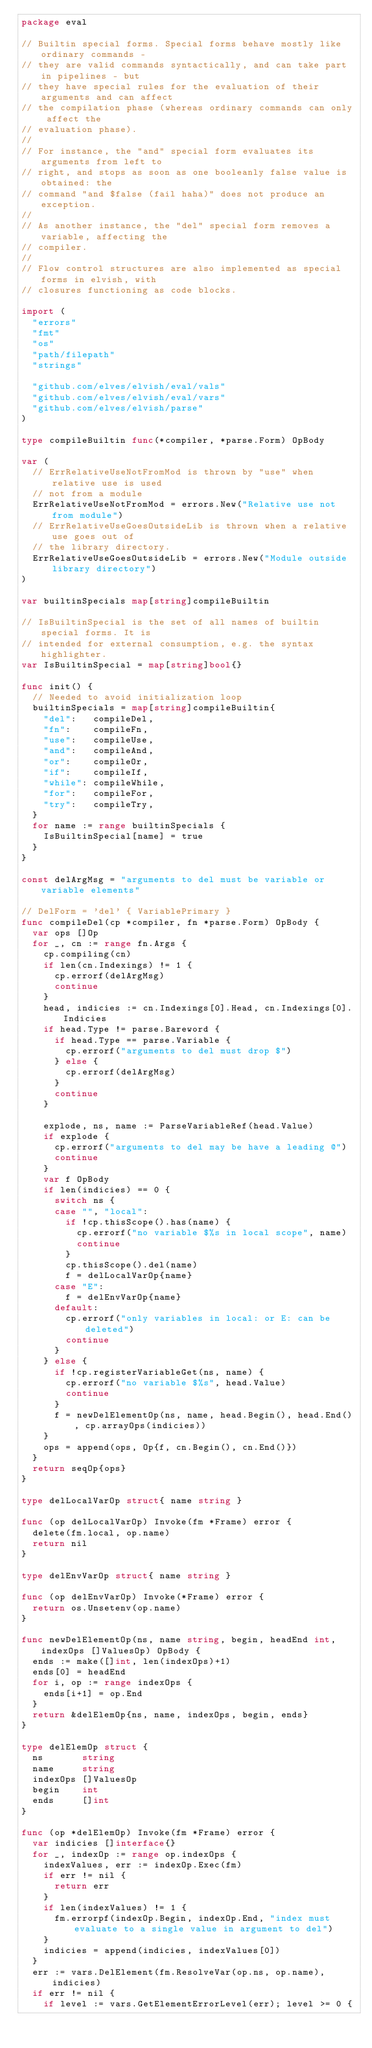Convert code to text. <code><loc_0><loc_0><loc_500><loc_500><_Go_>package eval

// Builtin special forms. Special forms behave mostly like ordinary commands -
// they are valid commands syntactically, and can take part in pipelines - but
// they have special rules for the evaluation of their arguments and can affect
// the compilation phase (whereas ordinary commands can only affect the
// evaluation phase).
//
// For instance, the "and" special form evaluates its arguments from left to
// right, and stops as soon as one booleanly false value is obtained: the
// command "and $false (fail haha)" does not produce an exception.
//
// As another instance, the "del" special form removes a variable, affecting the
// compiler.
//
// Flow control structures are also implemented as special forms in elvish, with
// closures functioning as code blocks.

import (
	"errors"
	"fmt"
	"os"
	"path/filepath"
	"strings"

	"github.com/elves/elvish/eval/vals"
	"github.com/elves/elvish/eval/vars"
	"github.com/elves/elvish/parse"
)

type compileBuiltin func(*compiler, *parse.Form) OpBody

var (
	// ErrRelativeUseNotFromMod is thrown by "use" when relative use is used
	// not from a module
	ErrRelativeUseNotFromMod = errors.New("Relative use not from module")
	// ErrRelativeUseGoesOutsideLib is thrown when a relative use goes out of
	// the library directory.
	ErrRelativeUseGoesOutsideLib = errors.New("Module outside library directory")
)

var builtinSpecials map[string]compileBuiltin

// IsBuiltinSpecial is the set of all names of builtin special forms. It is
// intended for external consumption, e.g. the syntax highlighter.
var IsBuiltinSpecial = map[string]bool{}

func init() {
	// Needed to avoid initialization loop
	builtinSpecials = map[string]compileBuiltin{
		"del":   compileDel,
		"fn":    compileFn,
		"use":   compileUse,
		"and":   compileAnd,
		"or":    compileOr,
		"if":    compileIf,
		"while": compileWhile,
		"for":   compileFor,
		"try":   compileTry,
	}
	for name := range builtinSpecials {
		IsBuiltinSpecial[name] = true
	}
}

const delArgMsg = "arguments to del must be variable or variable elements"

// DelForm = 'del' { VariablePrimary }
func compileDel(cp *compiler, fn *parse.Form) OpBody {
	var ops []Op
	for _, cn := range fn.Args {
		cp.compiling(cn)
		if len(cn.Indexings) != 1 {
			cp.errorf(delArgMsg)
			continue
		}
		head, indicies := cn.Indexings[0].Head, cn.Indexings[0].Indicies
		if head.Type != parse.Bareword {
			if head.Type == parse.Variable {
				cp.errorf("arguments to del must drop $")
			} else {
				cp.errorf(delArgMsg)
			}
			continue
		}

		explode, ns, name := ParseVariableRef(head.Value)
		if explode {
			cp.errorf("arguments to del may be have a leading @")
			continue
		}
		var f OpBody
		if len(indicies) == 0 {
			switch ns {
			case "", "local":
				if !cp.thisScope().has(name) {
					cp.errorf("no variable $%s in local scope", name)
					continue
				}
				cp.thisScope().del(name)
				f = delLocalVarOp{name}
			case "E":
				f = delEnvVarOp{name}
			default:
				cp.errorf("only variables in local: or E: can be deleted")
				continue
			}
		} else {
			if !cp.registerVariableGet(ns, name) {
				cp.errorf("no variable $%s", head.Value)
				continue
			}
			f = newDelElementOp(ns, name, head.Begin(), head.End(), cp.arrayOps(indicies))
		}
		ops = append(ops, Op{f, cn.Begin(), cn.End()})
	}
	return seqOp{ops}
}

type delLocalVarOp struct{ name string }

func (op delLocalVarOp) Invoke(fm *Frame) error {
	delete(fm.local, op.name)
	return nil
}

type delEnvVarOp struct{ name string }

func (op delEnvVarOp) Invoke(*Frame) error {
	return os.Unsetenv(op.name)
}

func newDelElementOp(ns, name string, begin, headEnd int, indexOps []ValuesOp) OpBody {
	ends := make([]int, len(indexOps)+1)
	ends[0] = headEnd
	for i, op := range indexOps {
		ends[i+1] = op.End
	}
	return &delElemOp{ns, name, indexOps, begin, ends}
}

type delElemOp struct {
	ns       string
	name     string
	indexOps []ValuesOp
	begin    int
	ends     []int
}

func (op *delElemOp) Invoke(fm *Frame) error {
	var indicies []interface{}
	for _, indexOp := range op.indexOps {
		indexValues, err := indexOp.Exec(fm)
		if err != nil {
			return err
		}
		if len(indexValues) != 1 {
			fm.errorpf(indexOp.Begin, indexOp.End, "index must evaluate to a single value in argument to del")
		}
		indicies = append(indicies, indexValues[0])
	}
	err := vars.DelElement(fm.ResolveVar(op.ns, op.name), indicies)
	if err != nil {
		if level := vars.GetElementErrorLevel(err); level >= 0 {</code> 